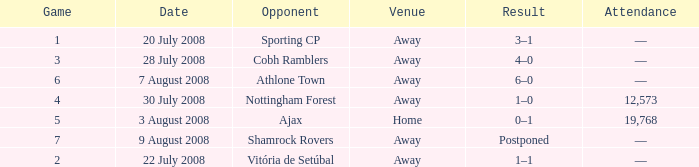What is the total game number with athlone town as the opponent? 1.0. 